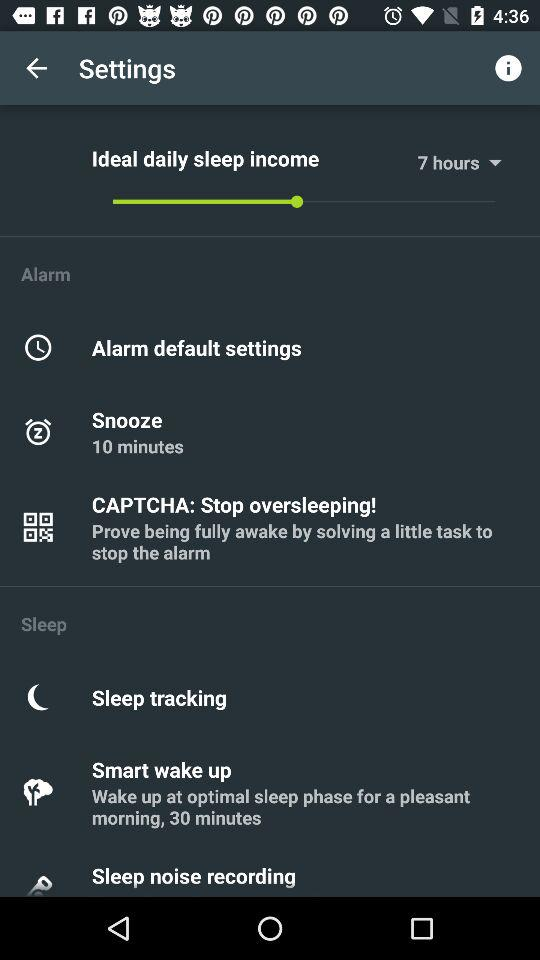What is the description of "Smart wake up"? The description of "Smart wake up" is "Wake up at optimal sleep phase for a pleasant morning, 30 minutes". 